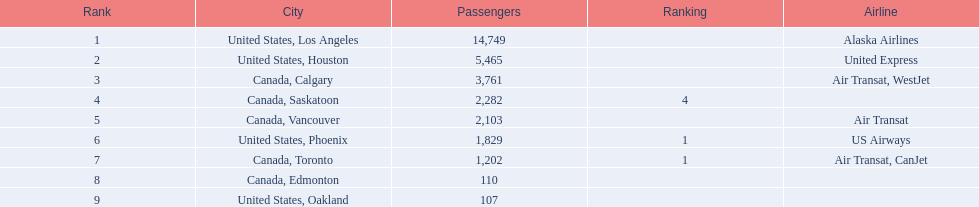How many airlines have a steady ranking? 4. 